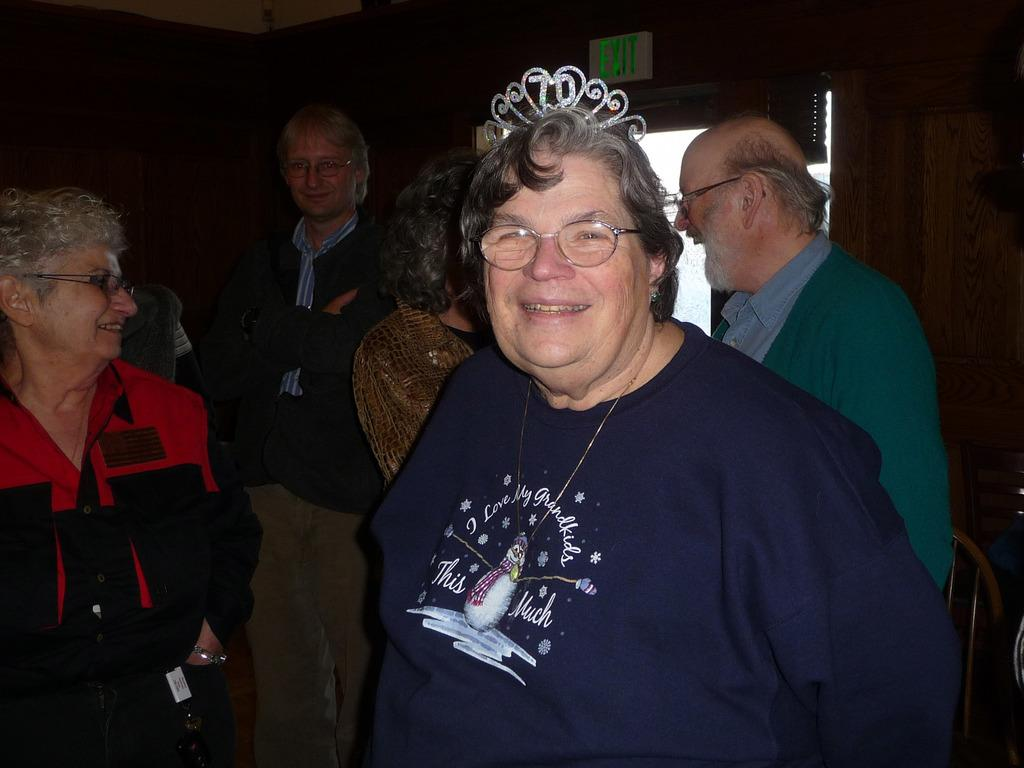What can be observed about the people in the image? There are people standing in the image. Can you describe any specific details about one of the individuals? A person in the front is wearing spectacles. What is located on the right side of the image? There is an exit board on the right side of the image. How would you describe the overall lighting in the image? The background of the image is dark. What type of stitch is being used to hold the bricks together in the image? There are no bricks or stitches present in the image. What material is the steel structure made of in the image? There is no steel structure present in the image. 